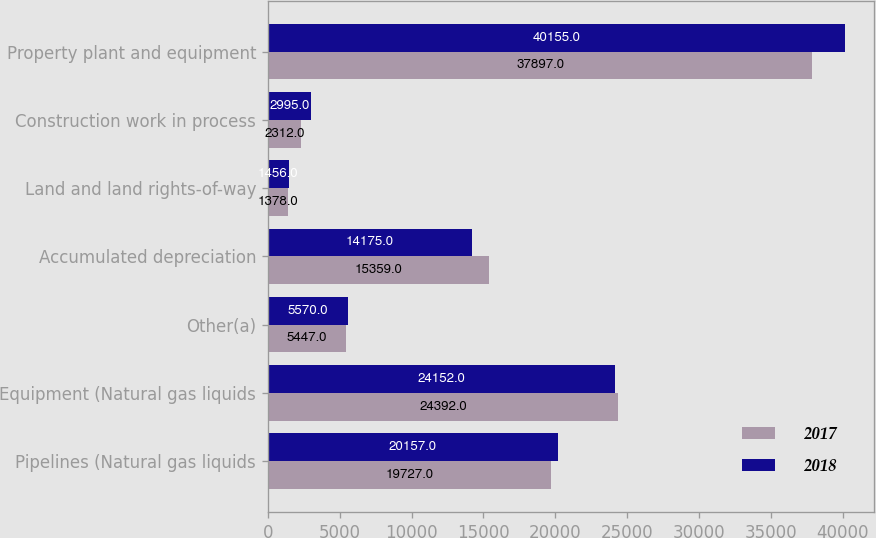<chart> <loc_0><loc_0><loc_500><loc_500><stacked_bar_chart><ecel><fcel>Pipelines (Natural gas liquids<fcel>Equipment (Natural gas liquids<fcel>Other(a)<fcel>Accumulated depreciation<fcel>Land and land rights-of-way<fcel>Construction work in process<fcel>Property plant and equipment<nl><fcel>2017<fcel>19727<fcel>24392<fcel>5447<fcel>15359<fcel>1378<fcel>2312<fcel>37897<nl><fcel>2018<fcel>20157<fcel>24152<fcel>5570<fcel>14175<fcel>1456<fcel>2995<fcel>40155<nl></chart> 